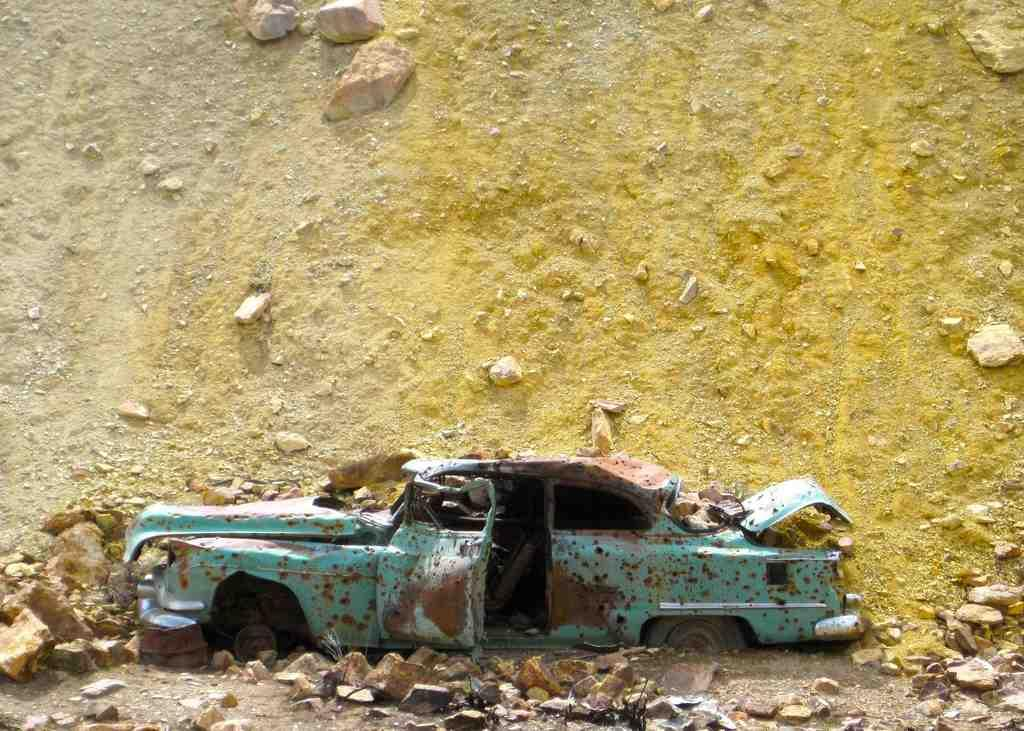What is the main subject of the image? The main subject of the image is a car. What other objects or features can be seen in the image? There are rocks and a mountain visible in the image. Can you tell me how many yaks are grazing near the car in the image? There are no yaks present in the image; it only features a car, rocks, and a mountain. What type of soap is being used to clean the car in the image? There is no soap or cleaning activity depicted in the image; it only shows a car, rocks, and a mountain. 